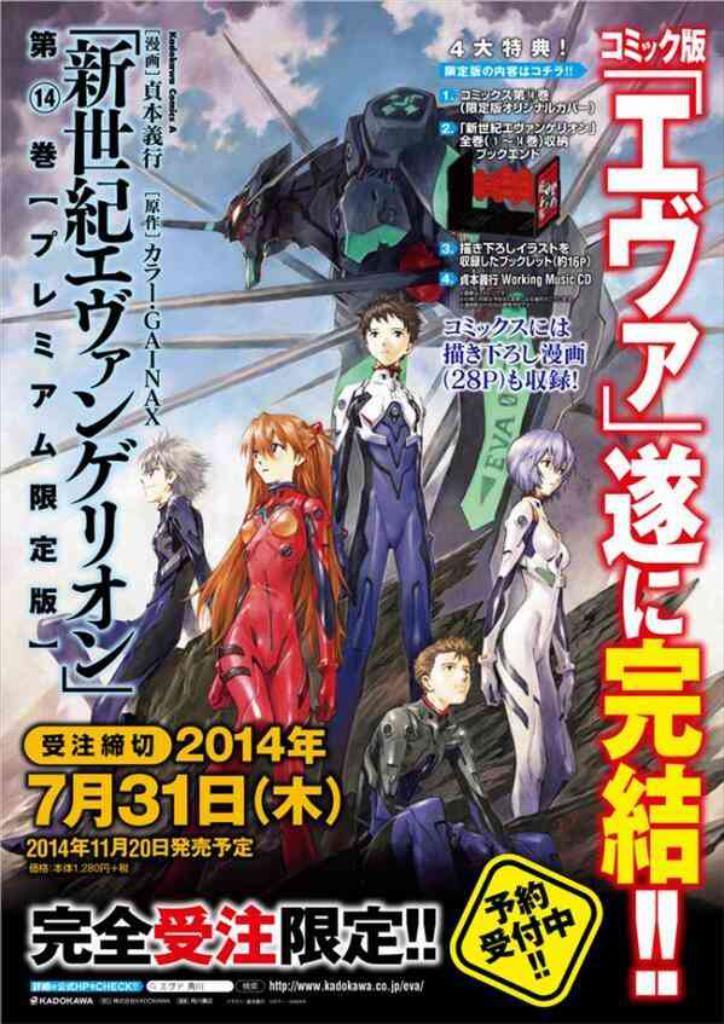Describe this image in one or two sentences. This is a poster and in this poster we can see animated characters and some text. 